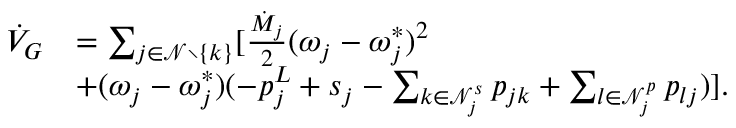Convert formula to latex. <formula><loc_0><loc_0><loc_500><loc_500>\begin{array} { r l } { \dot { V } _ { G } } & { = \sum _ { j \in \mathcal { N } \ \{ k \} } [ \frac { \dot { M } _ { j } } { 2 } ( \omega _ { j } - \omega _ { j } ^ { * } ) ^ { 2 } } \\ & { + ( \omega _ { j } - \omega _ { j } ^ { * } ) ( - p _ { j } ^ { L } + s _ { j } - \sum _ { k \in \mathcal { N } _ { j } ^ { s } } p _ { j k } + \sum _ { l \in \mathcal { N } _ { j } ^ { p } } p _ { l j } ) ] . } \end{array}</formula> 